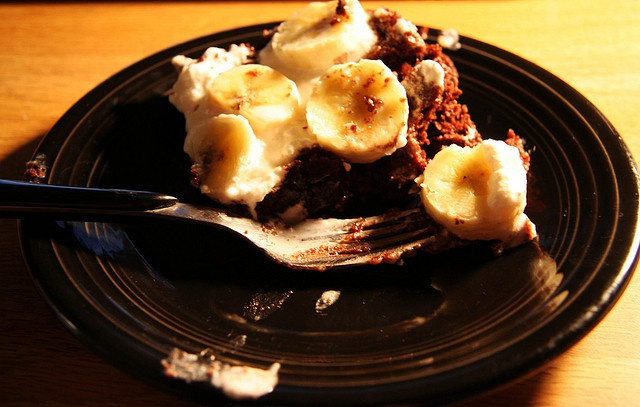Describe the objects in this image and their specific colors. I can see cake in black, khaki, gold, and ivory tones, banana in black, gold, khaki, and orange tones, fork in black, tan, and maroon tones, and banana in black, ivory, khaki, brown, and gold tones in this image. 